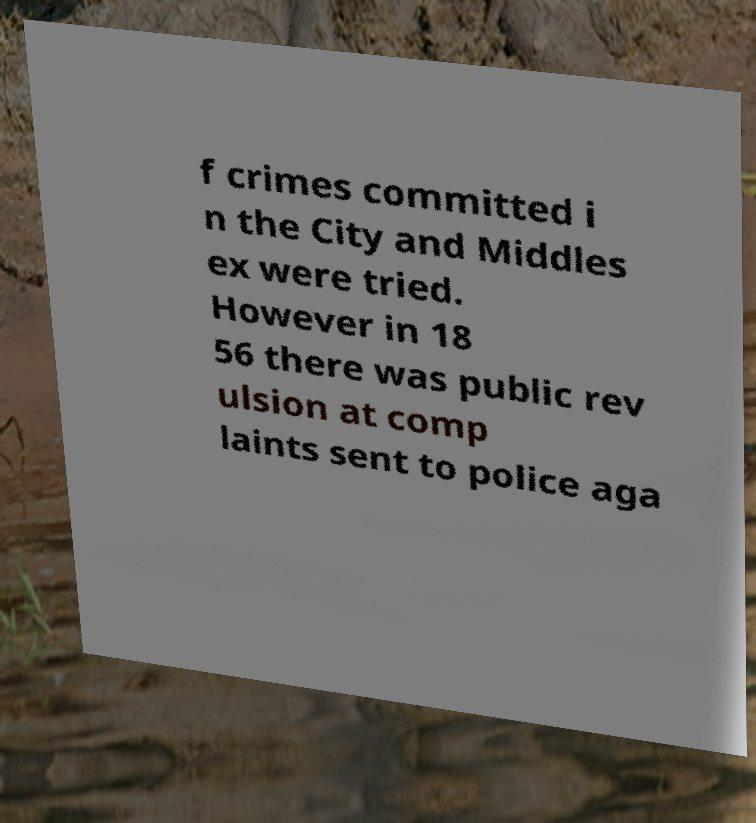Please read and relay the text visible in this image. What does it say? f crimes committed i n the City and Middles ex were tried. However in 18 56 there was public rev ulsion at comp laints sent to police aga 